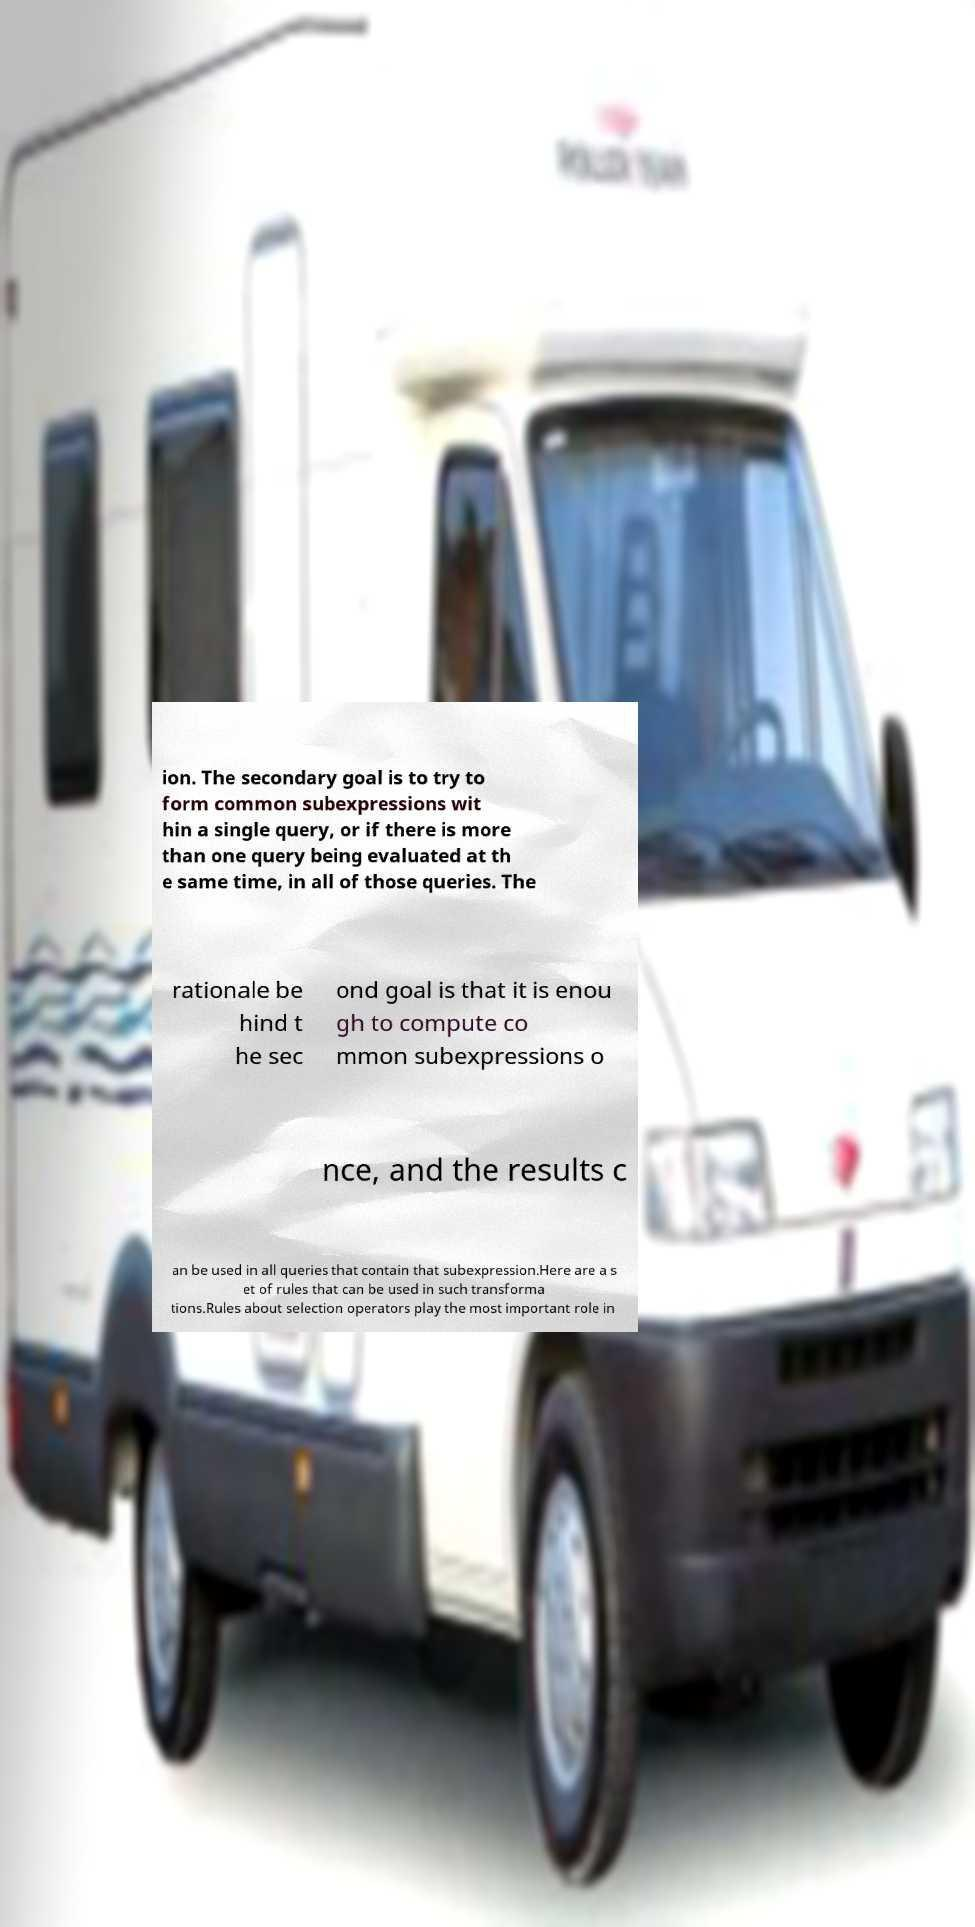Could you assist in decoding the text presented in this image and type it out clearly? ion. The secondary goal is to try to form common subexpressions wit hin a single query, or if there is more than one query being evaluated at th e same time, in all of those queries. The rationale be hind t he sec ond goal is that it is enou gh to compute co mmon subexpressions o nce, and the results c an be used in all queries that contain that subexpression.Here are a s et of rules that can be used in such transforma tions.Rules about selection operators play the most important role in 